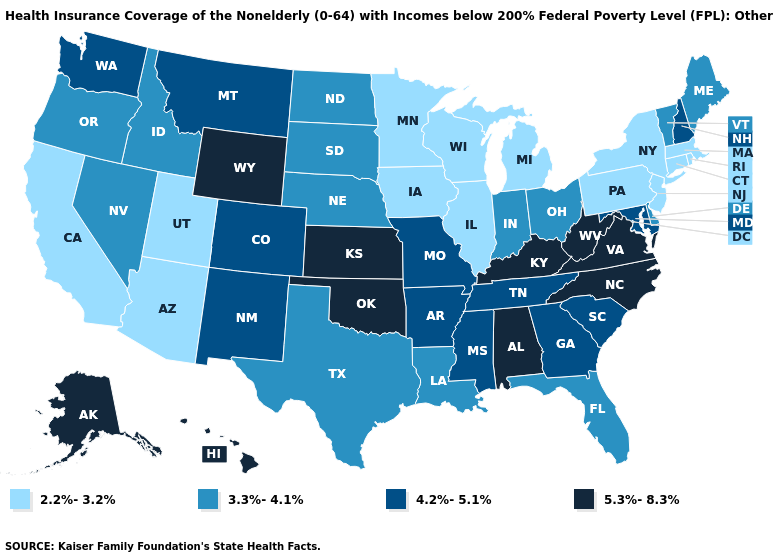What is the lowest value in states that border Maine?
Quick response, please. 4.2%-5.1%. What is the value of Illinois?
Concise answer only. 2.2%-3.2%. Does Florida have a higher value than West Virginia?
Quick response, please. No. Name the states that have a value in the range 5.3%-8.3%?
Give a very brief answer. Alabama, Alaska, Hawaii, Kansas, Kentucky, North Carolina, Oklahoma, Virginia, West Virginia, Wyoming. Name the states that have a value in the range 4.2%-5.1%?
Give a very brief answer. Arkansas, Colorado, Georgia, Maryland, Mississippi, Missouri, Montana, New Hampshire, New Mexico, South Carolina, Tennessee, Washington. Name the states that have a value in the range 2.2%-3.2%?
Concise answer only. Arizona, California, Connecticut, Illinois, Iowa, Massachusetts, Michigan, Minnesota, New Jersey, New York, Pennsylvania, Rhode Island, Utah, Wisconsin. What is the lowest value in the USA?
Answer briefly. 2.2%-3.2%. What is the value of Minnesota?
Answer briefly. 2.2%-3.2%. Among the states that border Michigan , does Indiana have the lowest value?
Give a very brief answer. No. What is the lowest value in states that border Idaho?
Give a very brief answer. 2.2%-3.2%. What is the lowest value in the USA?
Concise answer only. 2.2%-3.2%. What is the lowest value in states that border North Carolina?
Give a very brief answer. 4.2%-5.1%. Name the states that have a value in the range 4.2%-5.1%?
Concise answer only. Arkansas, Colorado, Georgia, Maryland, Mississippi, Missouri, Montana, New Hampshire, New Mexico, South Carolina, Tennessee, Washington. What is the value of New Hampshire?
Answer briefly. 4.2%-5.1%. 